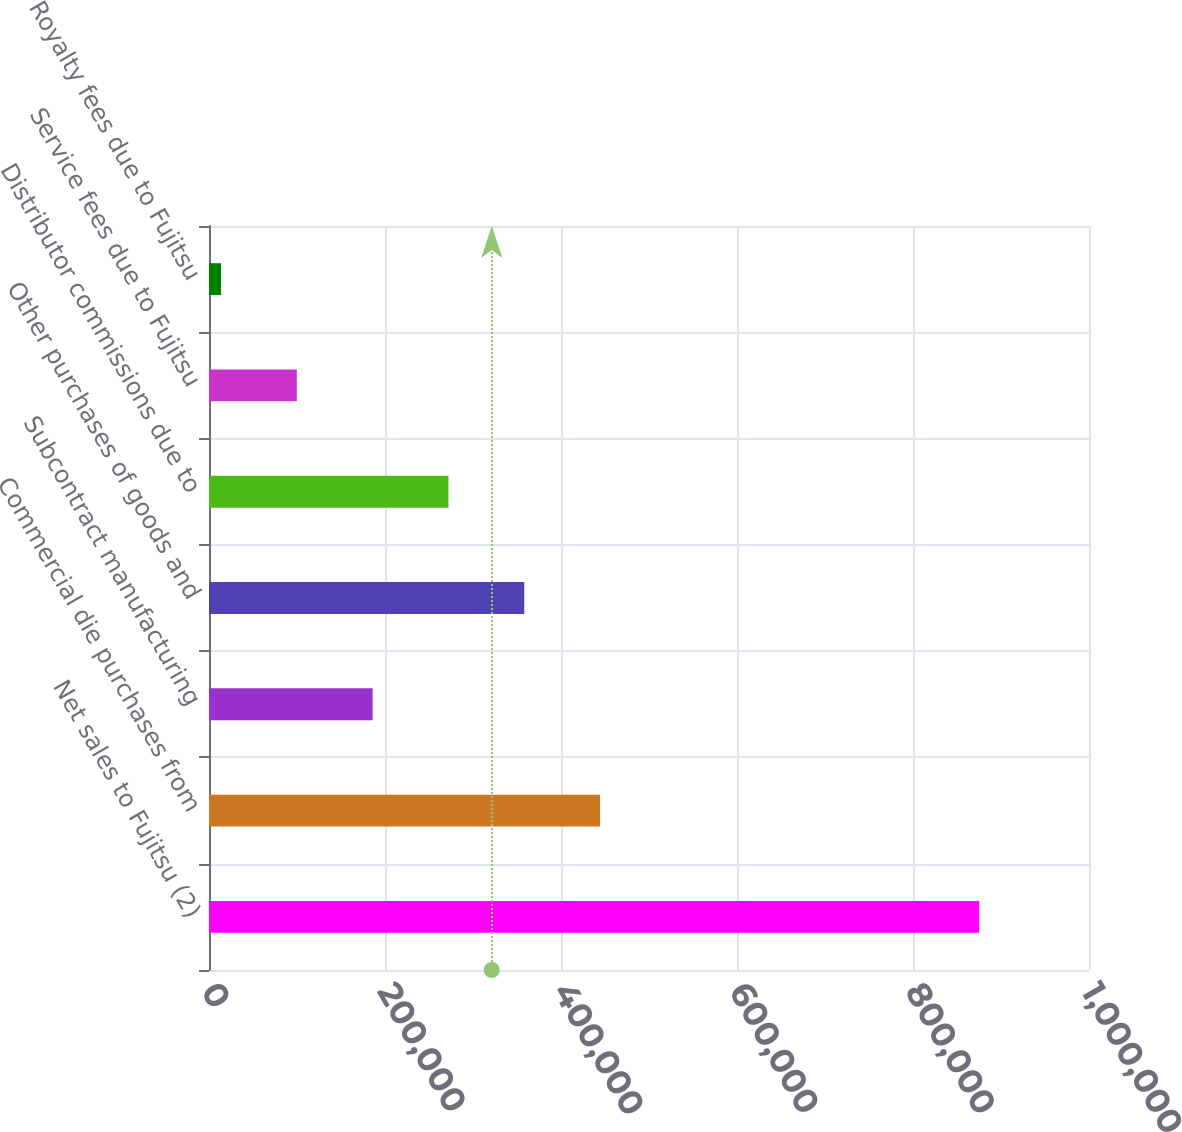<chart> <loc_0><loc_0><loc_500><loc_500><bar_chart><fcel>Net sales to Fujitsu (2)<fcel>Commercial die purchases from<fcel>Subcontract manufacturing<fcel>Other purchases of goods and<fcel>Distributor commissions due to<fcel>Service fees due to Fujitsu<fcel>Royalty fees due to Fujitsu<nl><fcel>875169<fcel>444402<fcel>185941<fcel>358248<fcel>272094<fcel>99787.5<fcel>13634<nl></chart> 